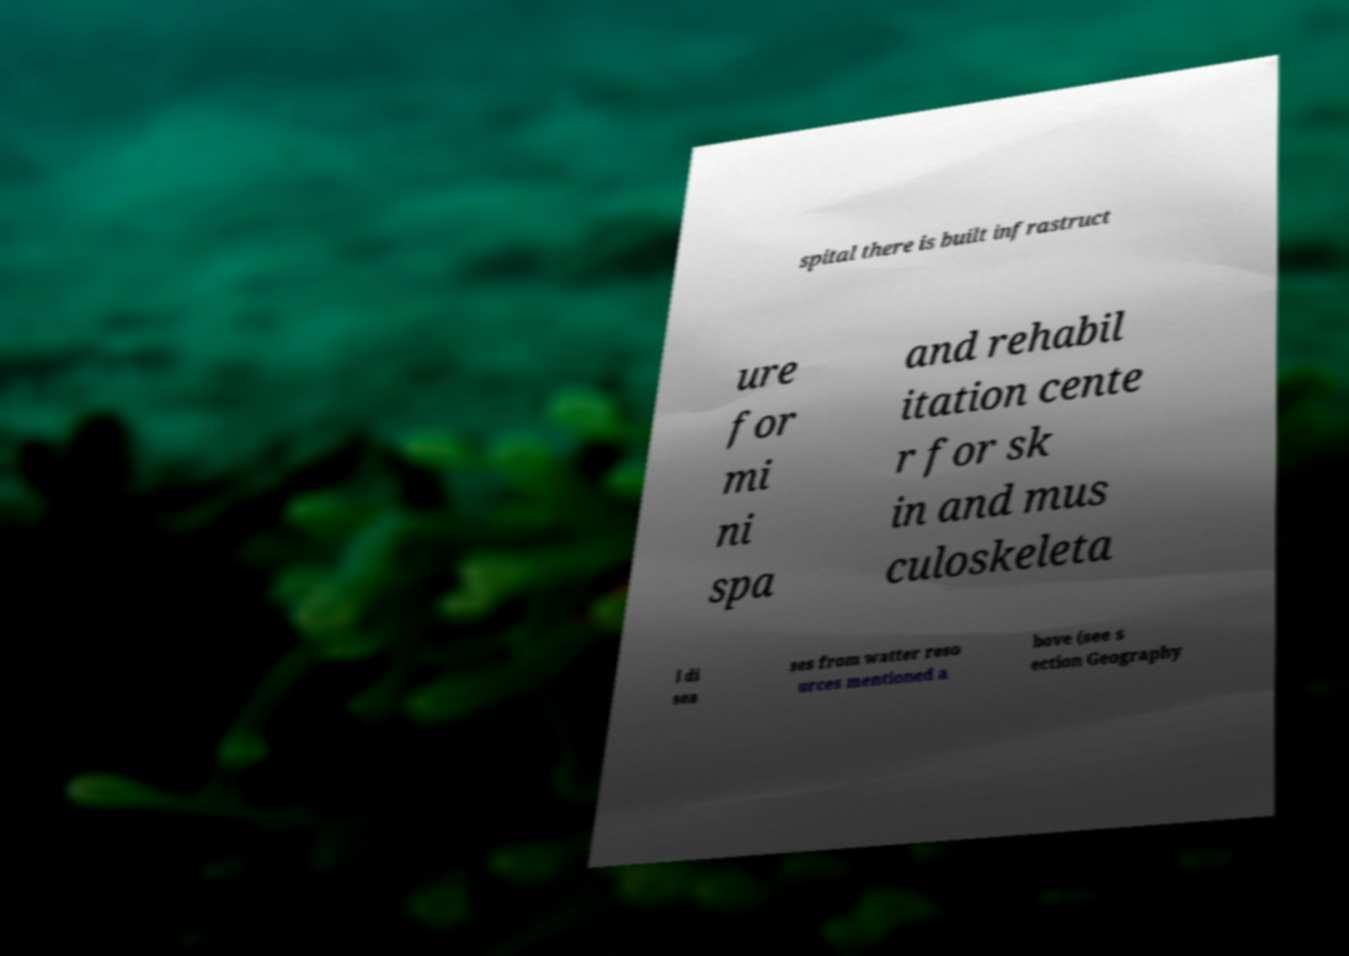For documentation purposes, I need the text within this image transcribed. Could you provide that? spital there is built infrastruct ure for mi ni spa and rehabil itation cente r for sk in and mus culoskeleta l di sea ses from watter reso urces mentioned a bove (see s ection Geography 